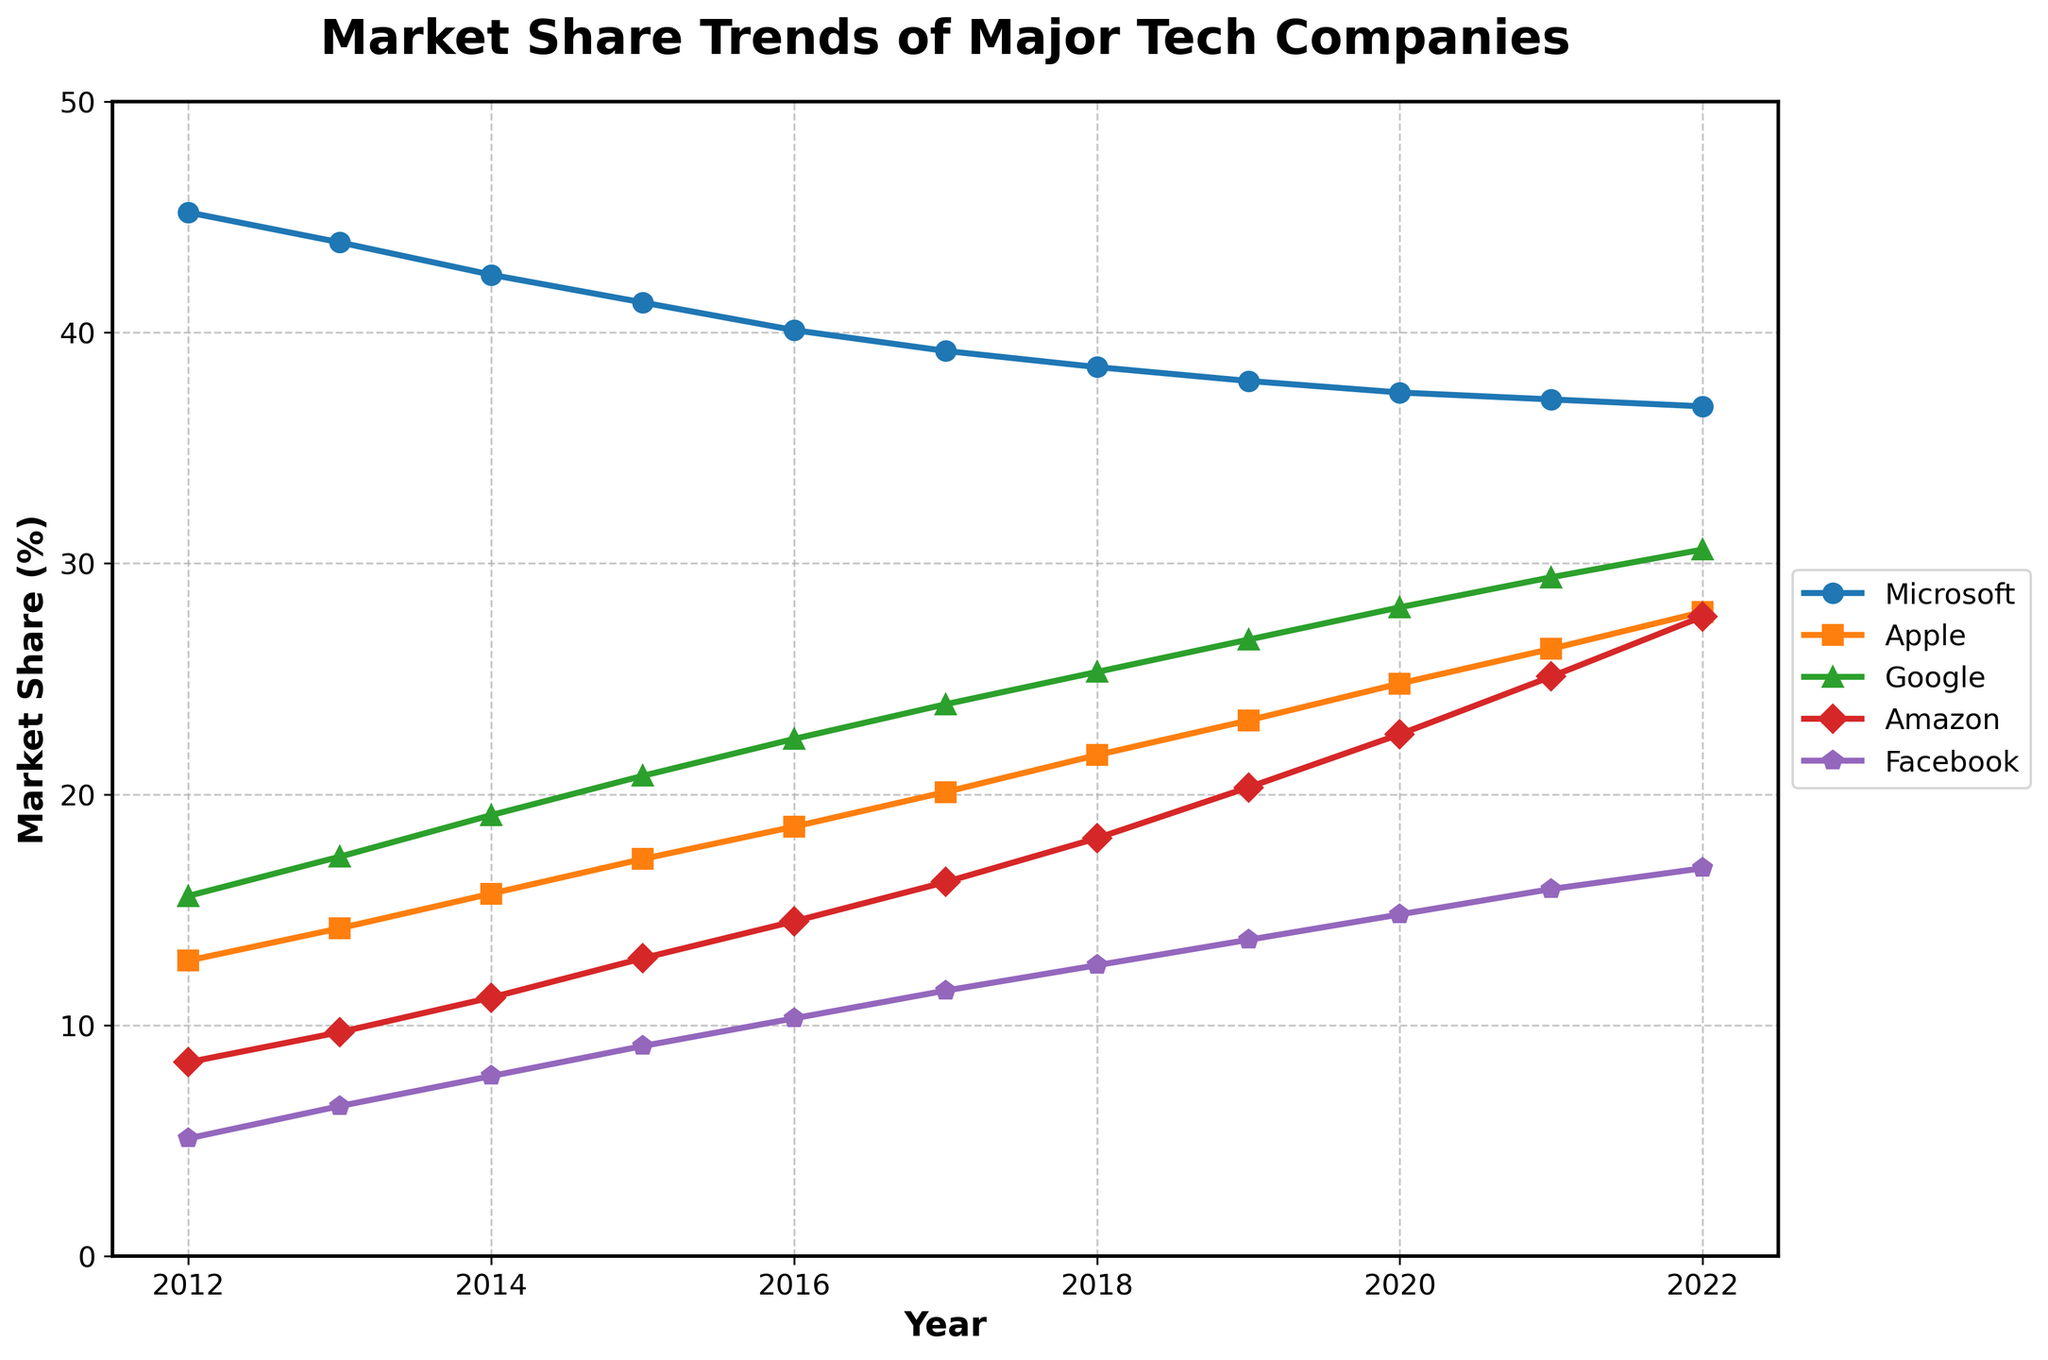What trend do you observe for Microsoft's market share from 2012 to 2022? Microsoft's market share shows a declining trend from 45.2% in 2012 to 36.8% in 2022.
Answer: Declining Between Apple and Amazon, which company had a higher growth rate in market share over the last decade? Apple's market share grew from 12.8% to 27.9%, an increase of 15.1 percentage points. Amazon's share grew from 8.4% to 27.7%, an increase of 19.3 percentage points. Therefore, Amazon had a higher growth rate.
Answer: Amazon Which company had the smallest market share increase from 2012 to 2022? Comparing the increases: Microsoft (-8.4), Apple (+15.1), Google (+15.0), Amazon (+19.3), Facebook (+11.7). Microsoft experienced a decrease, so the smallest increase was by Facebook.
Answer: Facebook At what year did Apple's market share surpass that of Google? By observing the plot, Apple's market share surpasses Google's in the year 2016.
Answer: 2016 What is the difference in market share between the highest and lowest companies in 2022? In 2022, Apple has the highest market share at 30.6% and Facebook has the lowest at 16.8%. The difference is 30.6 - 16.8 = 13.8%.
Answer: 13.8% Considering the market share trends, which company is likely to become the market leader if the trends continue? Considering the trends, Apple, with a consistent increase, might overtake Microsoft to become the market leader if the trends continue.
Answer: Apple In which year did Amazon's market share start increasing more rapidly than in previous years? Amazon's market share started increasing more rapidly from 2017 onwards, showing a steeper growth.
Answer: 2017 How many companies achieved a market share of at least 20% by 2022? By 2022, Apple (27.9%), Google (30.6%), and Amazon (27.7%) had market shares of at least 20%.
Answer: Three Which company had the highest market share growth in percentage terms from 2012 to 2022? Calculating percentage growth: Microsoft (-18.6%), Apple (+117.2%), Google (+96.2%), Amazon (+228.6%), Facebook (+229.4%). Facebook had the highest percentage growth.
Answer: Facebook Between 2015 and 2020, which company's market share grew the most in absolute percentage points? From 2015 to 2020, Microsoft's share dropped from 41.3% to 37.4% (-3.9), Apple's increased from 17.2% to 24.8% (+7.6), Google's from 20.8% to 28.1% (+7.3), Amazon's from 12.9% to 22.6% (+9.7), and Facebook's from 9.1% to 14.8% (+5.7). Amazon had the largest absolute growth.
Answer: Amazon 